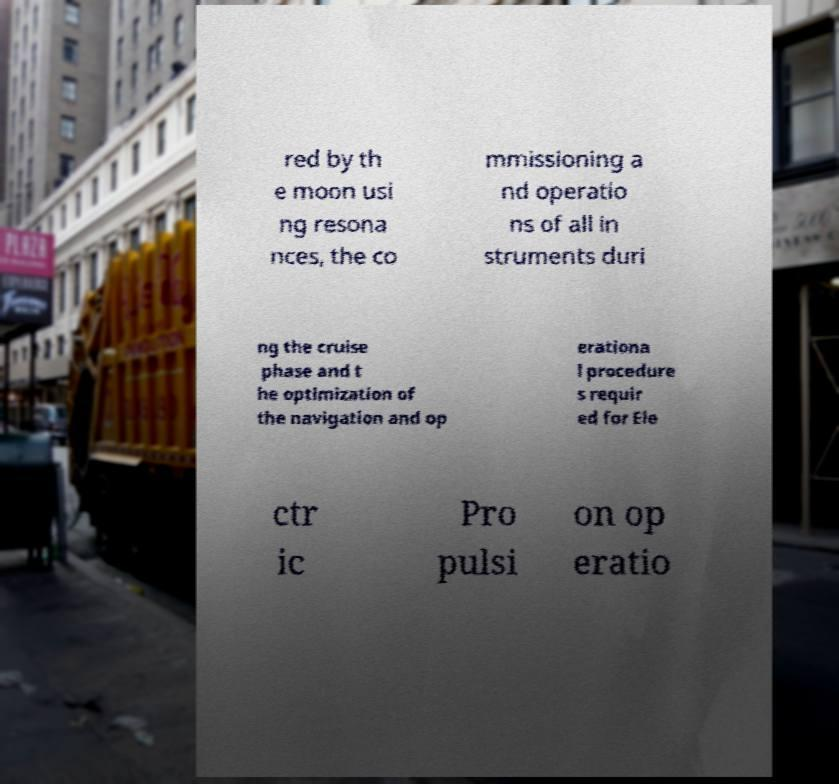For documentation purposes, I need the text within this image transcribed. Could you provide that? red by th e moon usi ng resona nces, the co mmissioning a nd operatio ns of all in struments duri ng the cruise phase and t he optimization of the navigation and op erationa l procedure s requir ed for Ele ctr ic Pro pulsi on op eratio 